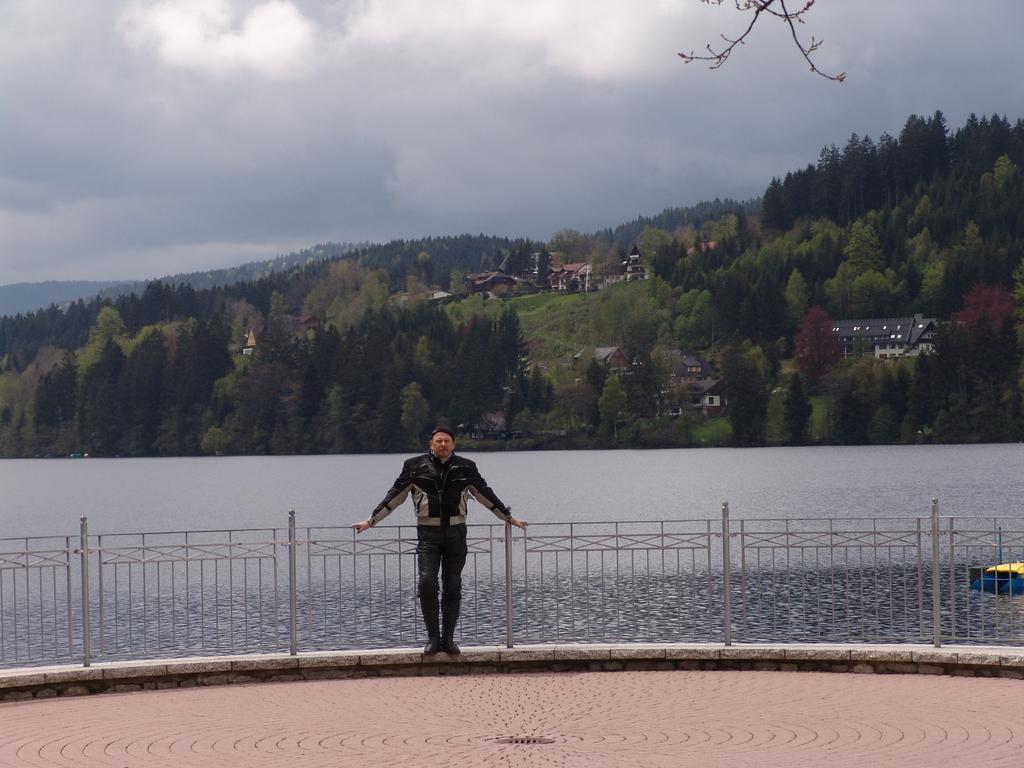Can you describe this image briefly? In the foreground of the picture there is a man standing near a railing, behind him there is water. In the center of the picture there are trees, hills and buildings. Sky is cloudy. At the top there is stem of a tree. 